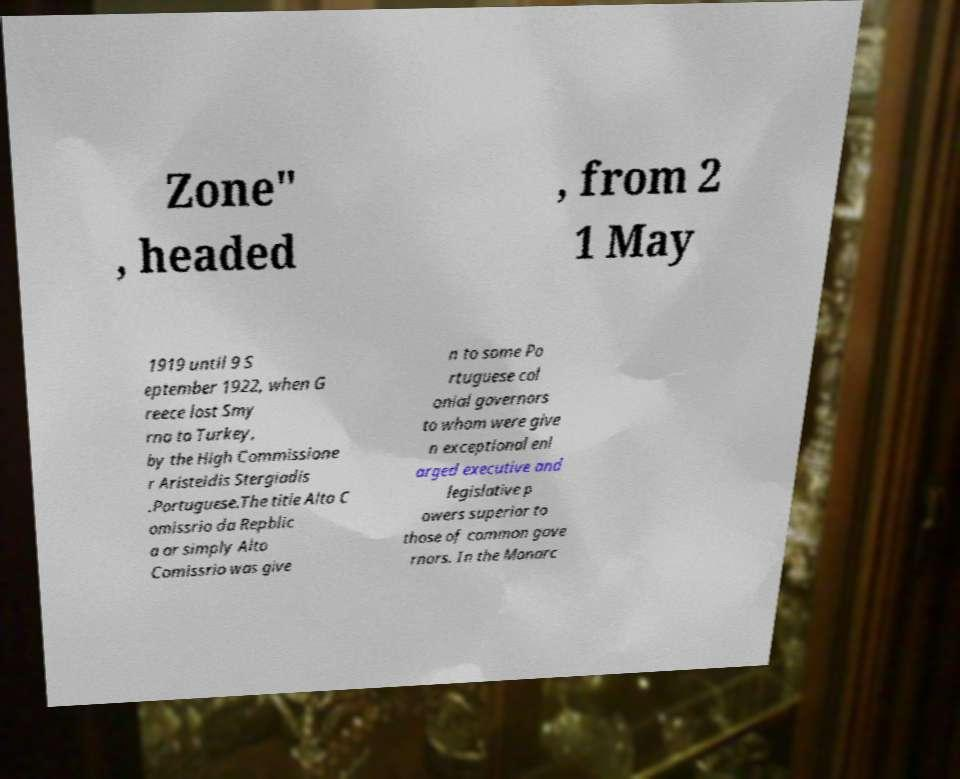There's text embedded in this image that I need extracted. Can you transcribe it verbatim? Zone" , headed , from 2 1 May 1919 until 9 S eptember 1922, when G reece lost Smy rna to Turkey, by the High Commissione r Aristeidis Stergiadis .Portuguese.The title Alto C omissrio da Repblic a or simply Alto Comissrio was give n to some Po rtuguese col onial governors to whom were give n exceptional enl arged executive and legislative p owers superior to those of common gove rnors. In the Monarc 